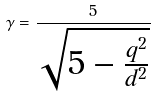<formula> <loc_0><loc_0><loc_500><loc_500>\gamma = \frac { 5 } { \sqrt { 5 - \frac { q ^ { 2 } } { d ^ { 2 } } } }</formula> 